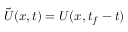Convert formula to latex. <formula><loc_0><loc_0><loc_500><loc_500>\tilde { U } ( { x } , t ) = U ( { x } , t _ { f } - t )</formula> 